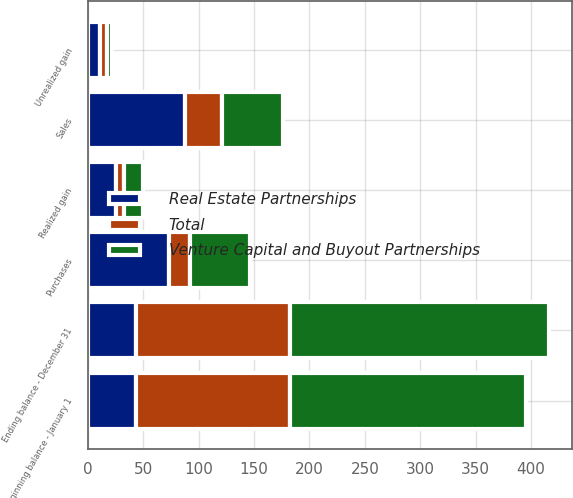<chart> <loc_0><loc_0><loc_500><loc_500><stacked_bar_chart><ecel><fcel>Beginning balance - January 1<fcel>Realized gain<fcel>Unrealized gain<fcel>Purchases<fcel>Sales<fcel>Ending balance - December 31<nl><fcel>Venture Capital and Buyout Partnerships<fcel>213<fcel>17<fcel>5<fcel>54<fcel>55<fcel>234<nl><fcel>Total<fcel>139<fcel>8<fcel>6<fcel>19<fcel>33<fcel>139<nl><fcel>Real Estate Partnerships<fcel>43.5<fcel>25<fcel>11<fcel>73<fcel>88<fcel>43.5<nl></chart> 